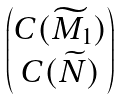Convert formula to latex. <formula><loc_0><loc_0><loc_500><loc_500>\begin{pmatrix} C ( \widetilde { M } _ { 1 } ) \\ C ( \widetilde { N } ) \end{pmatrix}</formula> 